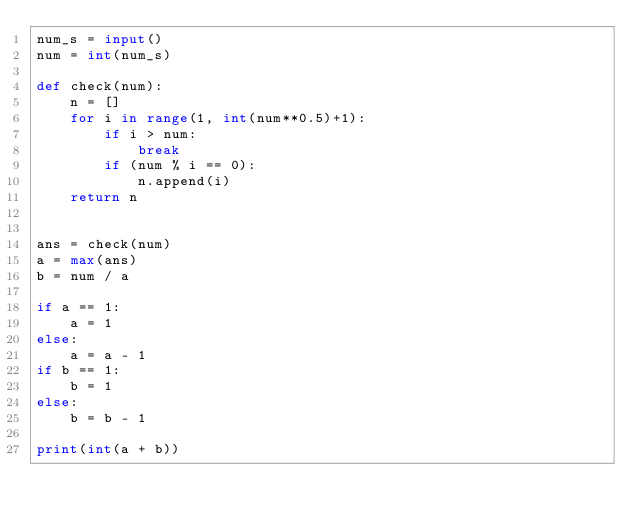<code> <loc_0><loc_0><loc_500><loc_500><_Python_>num_s = input()
num = int(num_s)

def check(num):
    n = []
    for i in range(1, int(num**0.5)+1):
        if i > num:
            break
        if (num % i == 0):
            n.append(i)
    return n


ans = check(num)
a = max(ans)
b = num / a

if a == 1:
    a = 1
else:
    a = a - 1
if b == 1:
    b = 1
else:
    b = b - 1

print(int(a + b))</code> 